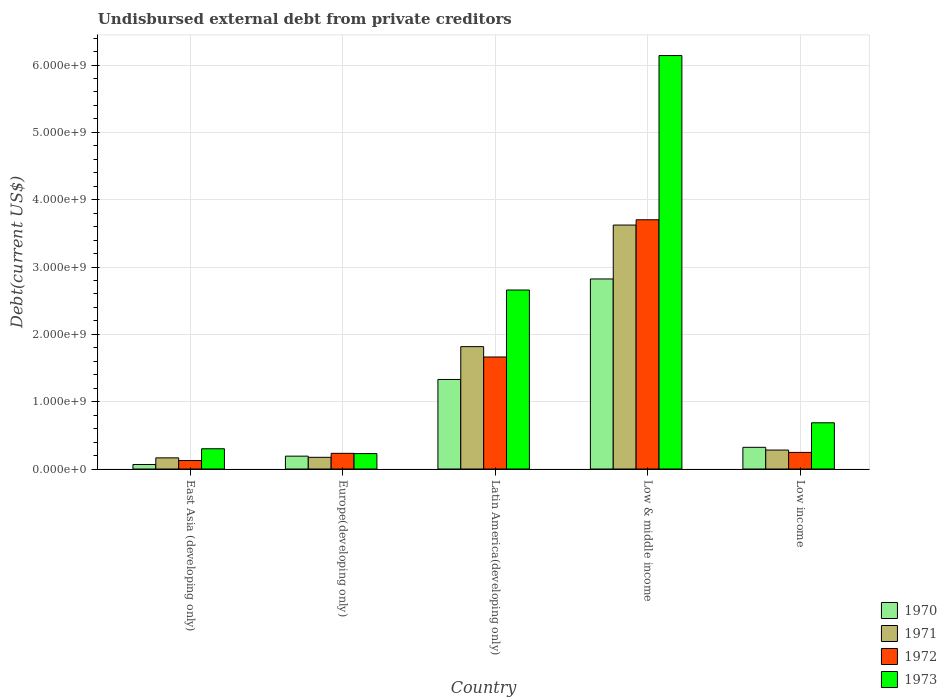How many groups of bars are there?
Offer a very short reply. 5. Are the number of bars per tick equal to the number of legend labels?
Give a very brief answer. Yes. What is the total debt in 1970 in Europe(developing only)?
Give a very brief answer. 1.91e+08. Across all countries, what is the maximum total debt in 1971?
Ensure brevity in your answer.  3.62e+09. Across all countries, what is the minimum total debt in 1971?
Offer a very short reply. 1.66e+08. In which country was the total debt in 1973 minimum?
Make the answer very short. Europe(developing only). What is the total total debt in 1972 in the graph?
Make the answer very short. 5.97e+09. What is the difference between the total debt in 1972 in Europe(developing only) and that in Low & middle income?
Your response must be concise. -3.47e+09. What is the difference between the total debt in 1973 in Low income and the total debt in 1970 in Low & middle income?
Your answer should be very brief. -2.14e+09. What is the average total debt in 1970 per country?
Offer a very short reply. 9.46e+08. What is the difference between the total debt of/in 1973 and total debt of/in 1972 in Low income?
Ensure brevity in your answer.  4.40e+08. In how many countries, is the total debt in 1970 greater than 4400000000 US$?
Give a very brief answer. 0. What is the ratio of the total debt in 1971 in Low & middle income to that in Low income?
Provide a succinct answer. 12.87. Is the total debt in 1973 in Europe(developing only) less than that in Low & middle income?
Provide a succinct answer. Yes. Is the difference between the total debt in 1973 in Low & middle income and Low income greater than the difference between the total debt in 1972 in Low & middle income and Low income?
Your answer should be compact. Yes. What is the difference between the highest and the second highest total debt in 1972?
Provide a short and direct response. 1.42e+09. What is the difference between the highest and the lowest total debt in 1972?
Provide a succinct answer. 3.58e+09. In how many countries, is the total debt in 1970 greater than the average total debt in 1970 taken over all countries?
Your answer should be compact. 2. Is it the case that in every country, the sum of the total debt in 1970 and total debt in 1972 is greater than the sum of total debt in 1971 and total debt in 1973?
Offer a very short reply. No. How many bars are there?
Provide a succinct answer. 20. Are all the bars in the graph horizontal?
Offer a very short reply. No. Are the values on the major ticks of Y-axis written in scientific E-notation?
Your response must be concise. Yes. Does the graph contain any zero values?
Ensure brevity in your answer.  No. Where does the legend appear in the graph?
Offer a very short reply. Bottom right. How are the legend labels stacked?
Keep it short and to the point. Vertical. What is the title of the graph?
Ensure brevity in your answer.  Undisbursed external debt from private creditors. What is the label or title of the X-axis?
Provide a short and direct response. Country. What is the label or title of the Y-axis?
Offer a very short reply. Debt(current US$). What is the Debt(current US$) of 1970 in East Asia (developing only)?
Provide a succinct answer. 6.68e+07. What is the Debt(current US$) in 1971 in East Asia (developing only)?
Offer a terse response. 1.66e+08. What is the Debt(current US$) of 1972 in East Asia (developing only)?
Keep it short and to the point. 1.26e+08. What is the Debt(current US$) in 1973 in East Asia (developing only)?
Provide a short and direct response. 3.01e+08. What is the Debt(current US$) of 1970 in Europe(developing only)?
Keep it short and to the point. 1.91e+08. What is the Debt(current US$) of 1971 in Europe(developing only)?
Make the answer very short. 1.74e+08. What is the Debt(current US$) in 1972 in Europe(developing only)?
Make the answer very short. 2.33e+08. What is the Debt(current US$) of 1973 in Europe(developing only)?
Your response must be concise. 2.29e+08. What is the Debt(current US$) of 1970 in Latin America(developing only)?
Offer a very short reply. 1.33e+09. What is the Debt(current US$) in 1971 in Latin America(developing only)?
Offer a terse response. 1.82e+09. What is the Debt(current US$) in 1972 in Latin America(developing only)?
Your answer should be compact. 1.66e+09. What is the Debt(current US$) in 1973 in Latin America(developing only)?
Provide a short and direct response. 2.66e+09. What is the Debt(current US$) in 1970 in Low & middle income?
Make the answer very short. 2.82e+09. What is the Debt(current US$) of 1971 in Low & middle income?
Keep it short and to the point. 3.62e+09. What is the Debt(current US$) in 1972 in Low & middle income?
Make the answer very short. 3.70e+09. What is the Debt(current US$) in 1973 in Low & middle income?
Offer a terse response. 6.14e+09. What is the Debt(current US$) in 1970 in Low income?
Ensure brevity in your answer.  3.22e+08. What is the Debt(current US$) in 1971 in Low income?
Provide a short and direct response. 2.82e+08. What is the Debt(current US$) in 1972 in Low income?
Offer a terse response. 2.47e+08. What is the Debt(current US$) of 1973 in Low income?
Keep it short and to the point. 6.86e+08. Across all countries, what is the maximum Debt(current US$) in 1970?
Your response must be concise. 2.82e+09. Across all countries, what is the maximum Debt(current US$) of 1971?
Provide a succinct answer. 3.62e+09. Across all countries, what is the maximum Debt(current US$) in 1972?
Ensure brevity in your answer.  3.70e+09. Across all countries, what is the maximum Debt(current US$) of 1973?
Provide a succinct answer. 6.14e+09. Across all countries, what is the minimum Debt(current US$) of 1970?
Your answer should be very brief. 6.68e+07. Across all countries, what is the minimum Debt(current US$) of 1971?
Offer a very short reply. 1.66e+08. Across all countries, what is the minimum Debt(current US$) in 1972?
Offer a very short reply. 1.26e+08. Across all countries, what is the minimum Debt(current US$) of 1973?
Give a very brief answer. 2.29e+08. What is the total Debt(current US$) of 1970 in the graph?
Keep it short and to the point. 4.73e+09. What is the total Debt(current US$) of 1971 in the graph?
Make the answer very short. 6.06e+09. What is the total Debt(current US$) of 1972 in the graph?
Provide a short and direct response. 5.97e+09. What is the total Debt(current US$) in 1973 in the graph?
Offer a terse response. 1.00e+1. What is the difference between the Debt(current US$) of 1970 in East Asia (developing only) and that in Europe(developing only)?
Your answer should be compact. -1.24e+08. What is the difference between the Debt(current US$) of 1971 in East Asia (developing only) and that in Europe(developing only)?
Keep it short and to the point. -7.94e+06. What is the difference between the Debt(current US$) of 1972 in East Asia (developing only) and that in Europe(developing only)?
Make the answer very short. -1.07e+08. What is the difference between the Debt(current US$) in 1973 in East Asia (developing only) and that in Europe(developing only)?
Give a very brief answer. 7.16e+07. What is the difference between the Debt(current US$) of 1970 in East Asia (developing only) and that in Latin America(developing only)?
Your answer should be compact. -1.26e+09. What is the difference between the Debt(current US$) of 1971 in East Asia (developing only) and that in Latin America(developing only)?
Offer a terse response. -1.65e+09. What is the difference between the Debt(current US$) of 1972 in East Asia (developing only) and that in Latin America(developing only)?
Your answer should be very brief. -1.54e+09. What is the difference between the Debt(current US$) of 1973 in East Asia (developing only) and that in Latin America(developing only)?
Keep it short and to the point. -2.36e+09. What is the difference between the Debt(current US$) in 1970 in East Asia (developing only) and that in Low & middle income?
Your answer should be compact. -2.76e+09. What is the difference between the Debt(current US$) of 1971 in East Asia (developing only) and that in Low & middle income?
Make the answer very short. -3.46e+09. What is the difference between the Debt(current US$) of 1972 in East Asia (developing only) and that in Low & middle income?
Your response must be concise. -3.58e+09. What is the difference between the Debt(current US$) of 1973 in East Asia (developing only) and that in Low & middle income?
Make the answer very short. -5.84e+09. What is the difference between the Debt(current US$) in 1970 in East Asia (developing only) and that in Low income?
Provide a short and direct response. -2.55e+08. What is the difference between the Debt(current US$) of 1971 in East Asia (developing only) and that in Low income?
Offer a very short reply. -1.16e+08. What is the difference between the Debt(current US$) of 1972 in East Asia (developing only) and that in Low income?
Give a very brief answer. -1.21e+08. What is the difference between the Debt(current US$) in 1973 in East Asia (developing only) and that in Low income?
Your response must be concise. -3.86e+08. What is the difference between the Debt(current US$) of 1970 in Europe(developing only) and that in Latin America(developing only)?
Make the answer very short. -1.14e+09. What is the difference between the Debt(current US$) in 1971 in Europe(developing only) and that in Latin America(developing only)?
Offer a terse response. -1.64e+09. What is the difference between the Debt(current US$) in 1972 in Europe(developing only) and that in Latin America(developing only)?
Offer a very short reply. -1.43e+09. What is the difference between the Debt(current US$) of 1973 in Europe(developing only) and that in Latin America(developing only)?
Provide a succinct answer. -2.43e+09. What is the difference between the Debt(current US$) of 1970 in Europe(developing only) and that in Low & middle income?
Your response must be concise. -2.63e+09. What is the difference between the Debt(current US$) of 1971 in Europe(developing only) and that in Low & middle income?
Provide a short and direct response. -3.45e+09. What is the difference between the Debt(current US$) of 1972 in Europe(developing only) and that in Low & middle income?
Ensure brevity in your answer.  -3.47e+09. What is the difference between the Debt(current US$) in 1973 in Europe(developing only) and that in Low & middle income?
Make the answer very short. -5.91e+09. What is the difference between the Debt(current US$) of 1970 in Europe(developing only) and that in Low income?
Ensure brevity in your answer.  -1.31e+08. What is the difference between the Debt(current US$) of 1971 in Europe(developing only) and that in Low income?
Keep it short and to the point. -1.08e+08. What is the difference between the Debt(current US$) of 1972 in Europe(developing only) and that in Low income?
Your answer should be compact. -1.39e+07. What is the difference between the Debt(current US$) of 1973 in Europe(developing only) and that in Low income?
Ensure brevity in your answer.  -4.57e+08. What is the difference between the Debt(current US$) in 1970 in Latin America(developing only) and that in Low & middle income?
Give a very brief answer. -1.49e+09. What is the difference between the Debt(current US$) in 1971 in Latin America(developing only) and that in Low & middle income?
Keep it short and to the point. -1.81e+09. What is the difference between the Debt(current US$) in 1972 in Latin America(developing only) and that in Low & middle income?
Provide a succinct answer. -2.04e+09. What is the difference between the Debt(current US$) in 1973 in Latin America(developing only) and that in Low & middle income?
Your response must be concise. -3.48e+09. What is the difference between the Debt(current US$) of 1970 in Latin America(developing only) and that in Low income?
Ensure brevity in your answer.  1.01e+09. What is the difference between the Debt(current US$) in 1971 in Latin America(developing only) and that in Low income?
Provide a succinct answer. 1.54e+09. What is the difference between the Debt(current US$) in 1972 in Latin America(developing only) and that in Low income?
Your answer should be compact. 1.42e+09. What is the difference between the Debt(current US$) in 1973 in Latin America(developing only) and that in Low income?
Offer a very short reply. 1.97e+09. What is the difference between the Debt(current US$) of 1970 in Low & middle income and that in Low income?
Your answer should be very brief. 2.50e+09. What is the difference between the Debt(current US$) in 1971 in Low & middle income and that in Low income?
Offer a terse response. 3.34e+09. What is the difference between the Debt(current US$) of 1972 in Low & middle income and that in Low income?
Provide a short and direct response. 3.45e+09. What is the difference between the Debt(current US$) in 1973 in Low & middle income and that in Low income?
Offer a very short reply. 5.45e+09. What is the difference between the Debt(current US$) of 1970 in East Asia (developing only) and the Debt(current US$) of 1971 in Europe(developing only)?
Give a very brief answer. -1.07e+08. What is the difference between the Debt(current US$) of 1970 in East Asia (developing only) and the Debt(current US$) of 1972 in Europe(developing only)?
Ensure brevity in your answer.  -1.66e+08. What is the difference between the Debt(current US$) of 1970 in East Asia (developing only) and the Debt(current US$) of 1973 in Europe(developing only)?
Make the answer very short. -1.62e+08. What is the difference between the Debt(current US$) of 1971 in East Asia (developing only) and the Debt(current US$) of 1972 in Europe(developing only)?
Provide a succinct answer. -6.72e+07. What is the difference between the Debt(current US$) of 1971 in East Asia (developing only) and the Debt(current US$) of 1973 in Europe(developing only)?
Your answer should be very brief. -6.35e+07. What is the difference between the Debt(current US$) in 1972 in East Asia (developing only) and the Debt(current US$) in 1973 in Europe(developing only)?
Offer a very short reply. -1.03e+08. What is the difference between the Debt(current US$) in 1970 in East Asia (developing only) and the Debt(current US$) in 1971 in Latin America(developing only)?
Your response must be concise. -1.75e+09. What is the difference between the Debt(current US$) in 1970 in East Asia (developing only) and the Debt(current US$) in 1972 in Latin America(developing only)?
Your response must be concise. -1.60e+09. What is the difference between the Debt(current US$) in 1970 in East Asia (developing only) and the Debt(current US$) in 1973 in Latin America(developing only)?
Give a very brief answer. -2.59e+09. What is the difference between the Debt(current US$) in 1971 in East Asia (developing only) and the Debt(current US$) in 1972 in Latin America(developing only)?
Ensure brevity in your answer.  -1.50e+09. What is the difference between the Debt(current US$) of 1971 in East Asia (developing only) and the Debt(current US$) of 1973 in Latin America(developing only)?
Your answer should be very brief. -2.49e+09. What is the difference between the Debt(current US$) of 1972 in East Asia (developing only) and the Debt(current US$) of 1973 in Latin America(developing only)?
Keep it short and to the point. -2.53e+09. What is the difference between the Debt(current US$) of 1970 in East Asia (developing only) and the Debt(current US$) of 1971 in Low & middle income?
Make the answer very short. -3.56e+09. What is the difference between the Debt(current US$) of 1970 in East Asia (developing only) and the Debt(current US$) of 1972 in Low & middle income?
Your response must be concise. -3.63e+09. What is the difference between the Debt(current US$) in 1970 in East Asia (developing only) and the Debt(current US$) in 1973 in Low & middle income?
Your answer should be very brief. -6.07e+09. What is the difference between the Debt(current US$) of 1971 in East Asia (developing only) and the Debt(current US$) of 1972 in Low & middle income?
Your response must be concise. -3.54e+09. What is the difference between the Debt(current US$) of 1971 in East Asia (developing only) and the Debt(current US$) of 1973 in Low & middle income?
Offer a very short reply. -5.97e+09. What is the difference between the Debt(current US$) in 1972 in East Asia (developing only) and the Debt(current US$) in 1973 in Low & middle income?
Your response must be concise. -6.01e+09. What is the difference between the Debt(current US$) of 1970 in East Asia (developing only) and the Debt(current US$) of 1971 in Low income?
Offer a very short reply. -2.15e+08. What is the difference between the Debt(current US$) of 1970 in East Asia (developing only) and the Debt(current US$) of 1972 in Low income?
Keep it short and to the point. -1.80e+08. What is the difference between the Debt(current US$) in 1970 in East Asia (developing only) and the Debt(current US$) in 1973 in Low income?
Provide a short and direct response. -6.20e+08. What is the difference between the Debt(current US$) in 1971 in East Asia (developing only) and the Debt(current US$) in 1972 in Low income?
Ensure brevity in your answer.  -8.11e+07. What is the difference between the Debt(current US$) of 1971 in East Asia (developing only) and the Debt(current US$) of 1973 in Low income?
Make the answer very short. -5.21e+08. What is the difference between the Debt(current US$) of 1972 in East Asia (developing only) and the Debt(current US$) of 1973 in Low income?
Your answer should be compact. -5.61e+08. What is the difference between the Debt(current US$) in 1970 in Europe(developing only) and the Debt(current US$) in 1971 in Latin America(developing only)?
Ensure brevity in your answer.  -1.63e+09. What is the difference between the Debt(current US$) of 1970 in Europe(developing only) and the Debt(current US$) of 1972 in Latin America(developing only)?
Provide a short and direct response. -1.47e+09. What is the difference between the Debt(current US$) of 1970 in Europe(developing only) and the Debt(current US$) of 1973 in Latin America(developing only)?
Ensure brevity in your answer.  -2.47e+09. What is the difference between the Debt(current US$) in 1971 in Europe(developing only) and the Debt(current US$) in 1972 in Latin America(developing only)?
Provide a short and direct response. -1.49e+09. What is the difference between the Debt(current US$) of 1971 in Europe(developing only) and the Debt(current US$) of 1973 in Latin America(developing only)?
Your answer should be compact. -2.48e+09. What is the difference between the Debt(current US$) in 1972 in Europe(developing only) and the Debt(current US$) in 1973 in Latin America(developing only)?
Ensure brevity in your answer.  -2.43e+09. What is the difference between the Debt(current US$) in 1970 in Europe(developing only) and the Debt(current US$) in 1971 in Low & middle income?
Your answer should be very brief. -3.43e+09. What is the difference between the Debt(current US$) in 1970 in Europe(developing only) and the Debt(current US$) in 1972 in Low & middle income?
Make the answer very short. -3.51e+09. What is the difference between the Debt(current US$) of 1970 in Europe(developing only) and the Debt(current US$) of 1973 in Low & middle income?
Keep it short and to the point. -5.95e+09. What is the difference between the Debt(current US$) of 1971 in Europe(developing only) and the Debt(current US$) of 1972 in Low & middle income?
Ensure brevity in your answer.  -3.53e+09. What is the difference between the Debt(current US$) in 1971 in Europe(developing only) and the Debt(current US$) in 1973 in Low & middle income?
Your answer should be compact. -5.97e+09. What is the difference between the Debt(current US$) in 1972 in Europe(developing only) and the Debt(current US$) in 1973 in Low & middle income?
Ensure brevity in your answer.  -5.91e+09. What is the difference between the Debt(current US$) in 1970 in Europe(developing only) and the Debt(current US$) in 1971 in Low income?
Provide a short and direct response. -9.05e+07. What is the difference between the Debt(current US$) of 1970 in Europe(developing only) and the Debt(current US$) of 1972 in Low income?
Offer a very short reply. -5.58e+07. What is the difference between the Debt(current US$) of 1970 in Europe(developing only) and the Debt(current US$) of 1973 in Low income?
Keep it short and to the point. -4.95e+08. What is the difference between the Debt(current US$) of 1971 in Europe(developing only) and the Debt(current US$) of 1972 in Low income?
Give a very brief answer. -7.31e+07. What is the difference between the Debt(current US$) of 1971 in Europe(developing only) and the Debt(current US$) of 1973 in Low income?
Provide a short and direct response. -5.13e+08. What is the difference between the Debt(current US$) of 1972 in Europe(developing only) and the Debt(current US$) of 1973 in Low income?
Ensure brevity in your answer.  -4.54e+08. What is the difference between the Debt(current US$) of 1970 in Latin America(developing only) and the Debt(current US$) of 1971 in Low & middle income?
Provide a succinct answer. -2.29e+09. What is the difference between the Debt(current US$) in 1970 in Latin America(developing only) and the Debt(current US$) in 1972 in Low & middle income?
Your answer should be very brief. -2.37e+09. What is the difference between the Debt(current US$) in 1970 in Latin America(developing only) and the Debt(current US$) in 1973 in Low & middle income?
Make the answer very short. -4.81e+09. What is the difference between the Debt(current US$) of 1971 in Latin America(developing only) and the Debt(current US$) of 1972 in Low & middle income?
Your response must be concise. -1.88e+09. What is the difference between the Debt(current US$) of 1971 in Latin America(developing only) and the Debt(current US$) of 1973 in Low & middle income?
Offer a very short reply. -4.32e+09. What is the difference between the Debt(current US$) of 1972 in Latin America(developing only) and the Debt(current US$) of 1973 in Low & middle income?
Offer a terse response. -4.48e+09. What is the difference between the Debt(current US$) in 1970 in Latin America(developing only) and the Debt(current US$) in 1971 in Low income?
Offer a very short reply. 1.05e+09. What is the difference between the Debt(current US$) of 1970 in Latin America(developing only) and the Debt(current US$) of 1972 in Low income?
Your response must be concise. 1.08e+09. What is the difference between the Debt(current US$) of 1970 in Latin America(developing only) and the Debt(current US$) of 1973 in Low income?
Provide a short and direct response. 6.43e+08. What is the difference between the Debt(current US$) of 1971 in Latin America(developing only) and the Debt(current US$) of 1972 in Low income?
Provide a short and direct response. 1.57e+09. What is the difference between the Debt(current US$) in 1971 in Latin America(developing only) and the Debt(current US$) in 1973 in Low income?
Ensure brevity in your answer.  1.13e+09. What is the difference between the Debt(current US$) of 1972 in Latin America(developing only) and the Debt(current US$) of 1973 in Low income?
Provide a succinct answer. 9.77e+08. What is the difference between the Debt(current US$) in 1970 in Low & middle income and the Debt(current US$) in 1971 in Low income?
Give a very brief answer. 2.54e+09. What is the difference between the Debt(current US$) in 1970 in Low & middle income and the Debt(current US$) in 1972 in Low income?
Offer a very short reply. 2.58e+09. What is the difference between the Debt(current US$) of 1970 in Low & middle income and the Debt(current US$) of 1973 in Low income?
Your answer should be compact. 2.14e+09. What is the difference between the Debt(current US$) of 1971 in Low & middle income and the Debt(current US$) of 1972 in Low income?
Provide a short and direct response. 3.38e+09. What is the difference between the Debt(current US$) in 1971 in Low & middle income and the Debt(current US$) in 1973 in Low income?
Ensure brevity in your answer.  2.94e+09. What is the difference between the Debt(current US$) of 1972 in Low & middle income and the Debt(current US$) of 1973 in Low income?
Keep it short and to the point. 3.02e+09. What is the average Debt(current US$) of 1970 per country?
Make the answer very short. 9.46e+08. What is the average Debt(current US$) of 1971 per country?
Your answer should be compact. 1.21e+09. What is the average Debt(current US$) of 1972 per country?
Ensure brevity in your answer.  1.19e+09. What is the average Debt(current US$) of 1973 per country?
Make the answer very short. 2.00e+09. What is the difference between the Debt(current US$) of 1970 and Debt(current US$) of 1971 in East Asia (developing only)?
Your answer should be compact. -9.89e+07. What is the difference between the Debt(current US$) in 1970 and Debt(current US$) in 1972 in East Asia (developing only)?
Keep it short and to the point. -5.90e+07. What is the difference between the Debt(current US$) in 1970 and Debt(current US$) in 1973 in East Asia (developing only)?
Provide a succinct answer. -2.34e+08. What is the difference between the Debt(current US$) of 1971 and Debt(current US$) of 1972 in East Asia (developing only)?
Offer a very short reply. 3.99e+07. What is the difference between the Debt(current US$) in 1971 and Debt(current US$) in 1973 in East Asia (developing only)?
Give a very brief answer. -1.35e+08. What is the difference between the Debt(current US$) in 1972 and Debt(current US$) in 1973 in East Asia (developing only)?
Keep it short and to the point. -1.75e+08. What is the difference between the Debt(current US$) of 1970 and Debt(current US$) of 1971 in Europe(developing only)?
Offer a terse response. 1.74e+07. What is the difference between the Debt(current US$) in 1970 and Debt(current US$) in 1972 in Europe(developing only)?
Offer a very short reply. -4.19e+07. What is the difference between the Debt(current US$) of 1970 and Debt(current US$) of 1973 in Europe(developing only)?
Make the answer very short. -3.81e+07. What is the difference between the Debt(current US$) in 1971 and Debt(current US$) in 1972 in Europe(developing only)?
Your answer should be very brief. -5.92e+07. What is the difference between the Debt(current US$) in 1971 and Debt(current US$) in 1973 in Europe(developing only)?
Your answer should be compact. -5.55e+07. What is the difference between the Debt(current US$) in 1972 and Debt(current US$) in 1973 in Europe(developing only)?
Your response must be concise. 3.73e+06. What is the difference between the Debt(current US$) in 1970 and Debt(current US$) in 1971 in Latin America(developing only)?
Provide a succinct answer. -4.88e+08. What is the difference between the Debt(current US$) in 1970 and Debt(current US$) in 1972 in Latin America(developing only)?
Your response must be concise. -3.34e+08. What is the difference between the Debt(current US$) of 1970 and Debt(current US$) of 1973 in Latin America(developing only)?
Your answer should be compact. -1.33e+09. What is the difference between the Debt(current US$) in 1971 and Debt(current US$) in 1972 in Latin America(developing only)?
Your answer should be very brief. 1.54e+08. What is the difference between the Debt(current US$) of 1971 and Debt(current US$) of 1973 in Latin America(developing only)?
Your answer should be compact. -8.41e+08. What is the difference between the Debt(current US$) of 1972 and Debt(current US$) of 1973 in Latin America(developing only)?
Offer a terse response. -9.95e+08. What is the difference between the Debt(current US$) of 1970 and Debt(current US$) of 1971 in Low & middle income?
Give a very brief answer. -8.01e+08. What is the difference between the Debt(current US$) of 1970 and Debt(current US$) of 1972 in Low & middle income?
Your answer should be compact. -8.79e+08. What is the difference between the Debt(current US$) of 1970 and Debt(current US$) of 1973 in Low & middle income?
Ensure brevity in your answer.  -3.32e+09. What is the difference between the Debt(current US$) of 1971 and Debt(current US$) of 1972 in Low & middle income?
Your response must be concise. -7.84e+07. What is the difference between the Debt(current US$) in 1971 and Debt(current US$) in 1973 in Low & middle income?
Offer a terse response. -2.52e+09. What is the difference between the Debt(current US$) in 1972 and Debt(current US$) in 1973 in Low & middle income?
Give a very brief answer. -2.44e+09. What is the difference between the Debt(current US$) of 1970 and Debt(current US$) of 1971 in Low income?
Offer a terse response. 4.06e+07. What is the difference between the Debt(current US$) in 1970 and Debt(current US$) in 1972 in Low income?
Offer a very short reply. 7.53e+07. What is the difference between the Debt(current US$) in 1970 and Debt(current US$) in 1973 in Low income?
Your answer should be very brief. -3.64e+08. What is the difference between the Debt(current US$) of 1971 and Debt(current US$) of 1972 in Low income?
Offer a very short reply. 3.47e+07. What is the difference between the Debt(current US$) in 1971 and Debt(current US$) in 1973 in Low income?
Your answer should be compact. -4.05e+08. What is the difference between the Debt(current US$) of 1972 and Debt(current US$) of 1973 in Low income?
Your response must be concise. -4.40e+08. What is the ratio of the Debt(current US$) in 1970 in East Asia (developing only) to that in Europe(developing only)?
Your answer should be very brief. 0.35. What is the ratio of the Debt(current US$) in 1971 in East Asia (developing only) to that in Europe(developing only)?
Provide a short and direct response. 0.95. What is the ratio of the Debt(current US$) in 1972 in East Asia (developing only) to that in Europe(developing only)?
Your answer should be compact. 0.54. What is the ratio of the Debt(current US$) of 1973 in East Asia (developing only) to that in Europe(developing only)?
Your answer should be very brief. 1.31. What is the ratio of the Debt(current US$) in 1970 in East Asia (developing only) to that in Latin America(developing only)?
Offer a terse response. 0.05. What is the ratio of the Debt(current US$) in 1971 in East Asia (developing only) to that in Latin America(developing only)?
Offer a very short reply. 0.09. What is the ratio of the Debt(current US$) in 1972 in East Asia (developing only) to that in Latin America(developing only)?
Offer a very short reply. 0.08. What is the ratio of the Debt(current US$) in 1973 in East Asia (developing only) to that in Latin America(developing only)?
Provide a short and direct response. 0.11. What is the ratio of the Debt(current US$) of 1970 in East Asia (developing only) to that in Low & middle income?
Ensure brevity in your answer.  0.02. What is the ratio of the Debt(current US$) in 1971 in East Asia (developing only) to that in Low & middle income?
Ensure brevity in your answer.  0.05. What is the ratio of the Debt(current US$) of 1972 in East Asia (developing only) to that in Low & middle income?
Give a very brief answer. 0.03. What is the ratio of the Debt(current US$) of 1973 in East Asia (developing only) to that in Low & middle income?
Your response must be concise. 0.05. What is the ratio of the Debt(current US$) of 1970 in East Asia (developing only) to that in Low income?
Your answer should be very brief. 0.21. What is the ratio of the Debt(current US$) in 1971 in East Asia (developing only) to that in Low income?
Offer a terse response. 0.59. What is the ratio of the Debt(current US$) of 1972 in East Asia (developing only) to that in Low income?
Provide a succinct answer. 0.51. What is the ratio of the Debt(current US$) in 1973 in East Asia (developing only) to that in Low income?
Offer a very short reply. 0.44. What is the ratio of the Debt(current US$) in 1970 in Europe(developing only) to that in Latin America(developing only)?
Provide a succinct answer. 0.14. What is the ratio of the Debt(current US$) of 1971 in Europe(developing only) to that in Latin America(developing only)?
Give a very brief answer. 0.1. What is the ratio of the Debt(current US$) in 1972 in Europe(developing only) to that in Latin America(developing only)?
Provide a succinct answer. 0.14. What is the ratio of the Debt(current US$) in 1973 in Europe(developing only) to that in Latin America(developing only)?
Give a very brief answer. 0.09. What is the ratio of the Debt(current US$) in 1970 in Europe(developing only) to that in Low & middle income?
Ensure brevity in your answer.  0.07. What is the ratio of the Debt(current US$) in 1971 in Europe(developing only) to that in Low & middle income?
Offer a very short reply. 0.05. What is the ratio of the Debt(current US$) in 1972 in Europe(developing only) to that in Low & middle income?
Keep it short and to the point. 0.06. What is the ratio of the Debt(current US$) in 1973 in Europe(developing only) to that in Low & middle income?
Offer a terse response. 0.04. What is the ratio of the Debt(current US$) in 1970 in Europe(developing only) to that in Low income?
Offer a terse response. 0.59. What is the ratio of the Debt(current US$) in 1971 in Europe(developing only) to that in Low income?
Offer a terse response. 0.62. What is the ratio of the Debt(current US$) in 1972 in Europe(developing only) to that in Low income?
Your response must be concise. 0.94. What is the ratio of the Debt(current US$) of 1973 in Europe(developing only) to that in Low income?
Your response must be concise. 0.33. What is the ratio of the Debt(current US$) of 1970 in Latin America(developing only) to that in Low & middle income?
Give a very brief answer. 0.47. What is the ratio of the Debt(current US$) of 1971 in Latin America(developing only) to that in Low & middle income?
Offer a very short reply. 0.5. What is the ratio of the Debt(current US$) in 1972 in Latin America(developing only) to that in Low & middle income?
Make the answer very short. 0.45. What is the ratio of the Debt(current US$) of 1973 in Latin America(developing only) to that in Low & middle income?
Provide a succinct answer. 0.43. What is the ratio of the Debt(current US$) in 1970 in Latin America(developing only) to that in Low income?
Offer a very short reply. 4.13. What is the ratio of the Debt(current US$) in 1971 in Latin America(developing only) to that in Low income?
Give a very brief answer. 6.46. What is the ratio of the Debt(current US$) of 1972 in Latin America(developing only) to that in Low income?
Give a very brief answer. 6.74. What is the ratio of the Debt(current US$) in 1973 in Latin America(developing only) to that in Low income?
Offer a terse response. 3.87. What is the ratio of the Debt(current US$) of 1970 in Low & middle income to that in Low income?
Keep it short and to the point. 8.76. What is the ratio of the Debt(current US$) of 1971 in Low & middle income to that in Low income?
Your answer should be very brief. 12.87. What is the ratio of the Debt(current US$) in 1972 in Low & middle income to that in Low income?
Your answer should be very brief. 15. What is the ratio of the Debt(current US$) of 1973 in Low & middle income to that in Low income?
Offer a very short reply. 8.95. What is the difference between the highest and the second highest Debt(current US$) of 1970?
Keep it short and to the point. 1.49e+09. What is the difference between the highest and the second highest Debt(current US$) in 1971?
Provide a succinct answer. 1.81e+09. What is the difference between the highest and the second highest Debt(current US$) in 1972?
Give a very brief answer. 2.04e+09. What is the difference between the highest and the second highest Debt(current US$) in 1973?
Keep it short and to the point. 3.48e+09. What is the difference between the highest and the lowest Debt(current US$) in 1970?
Provide a short and direct response. 2.76e+09. What is the difference between the highest and the lowest Debt(current US$) of 1971?
Provide a short and direct response. 3.46e+09. What is the difference between the highest and the lowest Debt(current US$) of 1972?
Make the answer very short. 3.58e+09. What is the difference between the highest and the lowest Debt(current US$) in 1973?
Offer a terse response. 5.91e+09. 